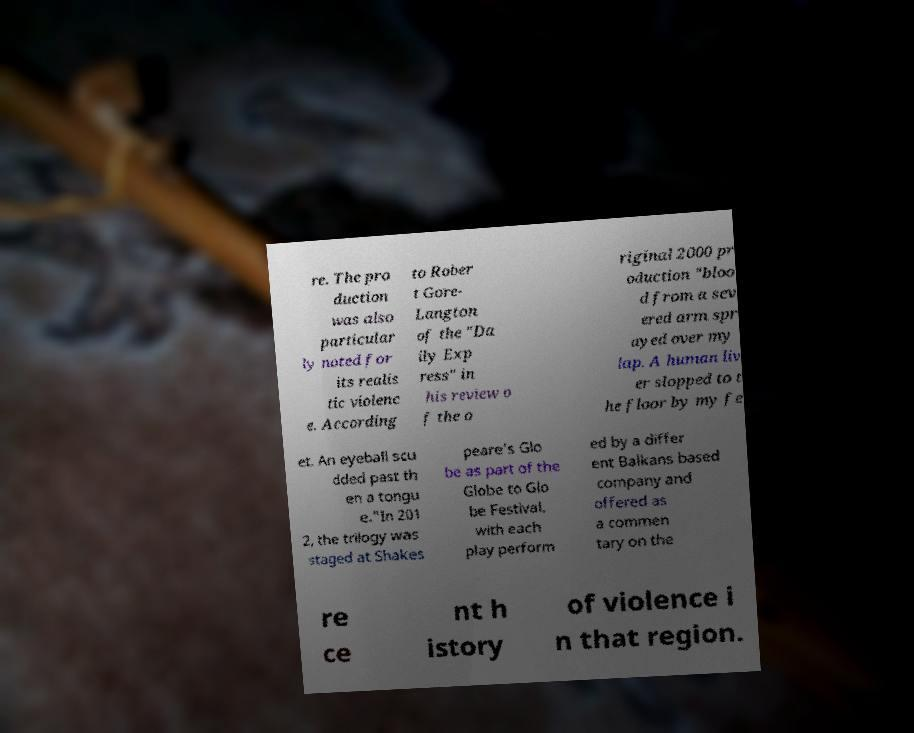There's text embedded in this image that I need extracted. Can you transcribe it verbatim? re. The pro duction was also particular ly noted for its realis tic violenc e. According to Rober t Gore- Langton of the "Da ily Exp ress" in his review o f the o riginal 2000 pr oduction "bloo d from a sev ered arm spr ayed over my lap. A human liv er slopped to t he floor by my fe et. An eyeball scu dded past th en a tongu e."In 201 2, the trilogy was staged at Shakes peare's Glo be as part of the Globe to Glo be Festival, with each play perform ed by a differ ent Balkans based company and offered as a commen tary on the re ce nt h istory of violence i n that region. 